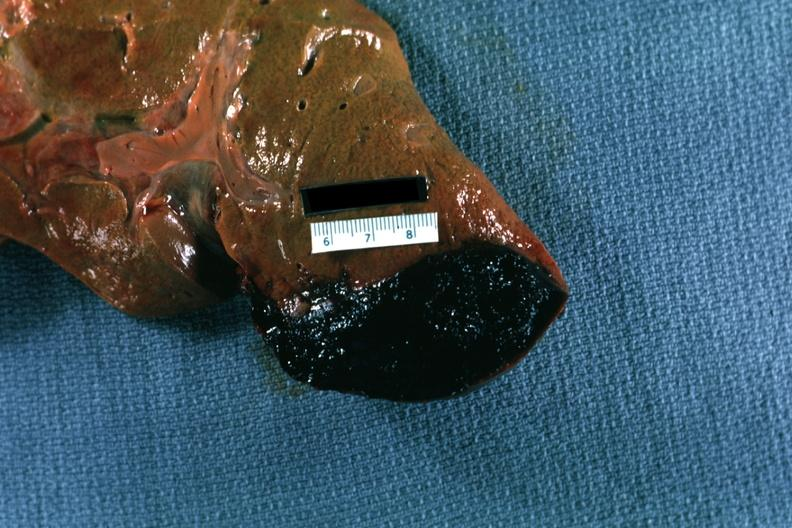s hepatobiliary present?
Answer the question using a single word or phrase. Yes 